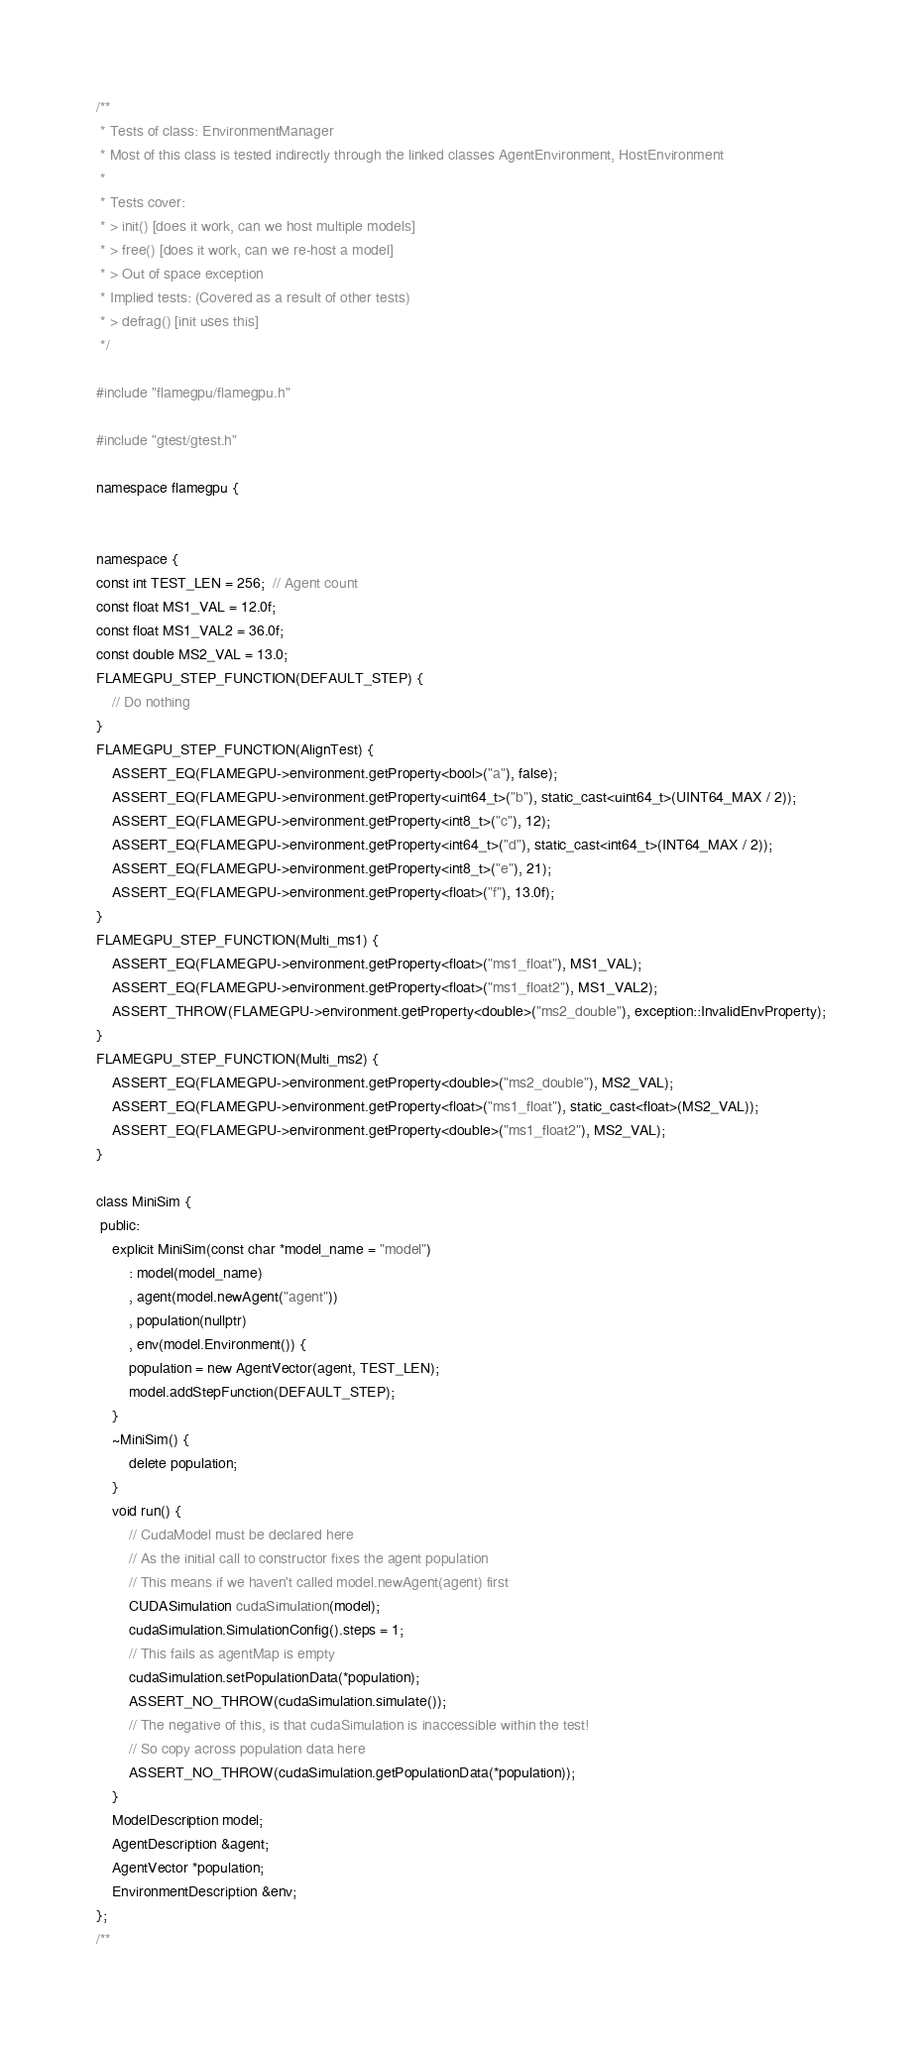<code> <loc_0><loc_0><loc_500><loc_500><_Cuda_>/**
 * Tests of class: EnvironmentManager
 * Most of this class is tested indirectly through the linked classes AgentEnvironment, HostEnvironment
 * 
 * Tests cover:
 * > init() [does it work, can we host multiple models]
 * > free() [does it work, can we re-host a model]
 * > Out of space exception
 * Implied tests: (Covered as a result of other tests)
 * > defrag() [init uses this]
 */

#include "flamegpu/flamegpu.h"

#include "gtest/gtest.h"

namespace flamegpu {


namespace {
const int TEST_LEN = 256;  // Agent count
const float MS1_VAL = 12.0f;
const float MS1_VAL2 = 36.0f;
const double MS2_VAL = 13.0;
FLAMEGPU_STEP_FUNCTION(DEFAULT_STEP) {
    // Do nothing
}
FLAMEGPU_STEP_FUNCTION(AlignTest) {
    ASSERT_EQ(FLAMEGPU->environment.getProperty<bool>("a"), false);
    ASSERT_EQ(FLAMEGPU->environment.getProperty<uint64_t>("b"), static_cast<uint64_t>(UINT64_MAX / 2));
    ASSERT_EQ(FLAMEGPU->environment.getProperty<int8_t>("c"), 12);
    ASSERT_EQ(FLAMEGPU->environment.getProperty<int64_t>("d"), static_cast<int64_t>(INT64_MAX / 2));
    ASSERT_EQ(FLAMEGPU->environment.getProperty<int8_t>("e"), 21);
    ASSERT_EQ(FLAMEGPU->environment.getProperty<float>("f"), 13.0f);
}
FLAMEGPU_STEP_FUNCTION(Multi_ms1) {
    ASSERT_EQ(FLAMEGPU->environment.getProperty<float>("ms1_float"), MS1_VAL);
    ASSERT_EQ(FLAMEGPU->environment.getProperty<float>("ms1_float2"), MS1_VAL2);
    ASSERT_THROW(FLAMEGPU->environment.getProperty<double>("ms2_double"), exception::InvalidEnvProperty);
}
FLAMEGPU_STEP_FUNCTION(Multi_ms2) {
    ASSERT_EQ(FLAMEGPU->environment.getProperty<double>("ms2_double"), MS2_VAL);
    ASSERT_EQ(FLAMEGPU->environment.getProperty<float>("ms1_float"), static_cast<float>(MS2_VAL));
    ASSERT_EQ(FLAMEGPU->environment.getProperty<double>("ms1_float2"), MS2_VAL);
}

class MiniSim {
 public:
    explicit MiniSim(const char *model_name = "model")
        : model(model_name)
        , agent(model.newAgent("agent"))
        , population(nullptr)
        , env(model.Environment()) {
        population = new AgentVector(agent, TEST_LEN);
        model.addStepFunction(DEFAULT_STEP);
    }
    ~MiniSim() {
        delete population;
    }
    void run() {
        // CudaModel must be declared here
        // As the initial call to constructor fixes the agent population
        // This means if we haven't called model.newAgent(agent) first
        CUDASimulation cudaSimulation(model);
        cudaSimulation.SimulationConfig().steps = 1;
        // This fails as agentMap is empty
        cudaSimulation.setPopulationData(*population);
        ASSERT_NO_THROW(cudaSimulation.simulate());
        // The negative of this, is that cudaSimulation is inaccessible within the test!
        // So copy across population data here
        ASSERT_NO_THROW(cudaSimulation.getPopulationData(*population));
    }
    ModelDescription model;
    AgentDescription &agent;
    AgentVector *population;
    EnvironmentDescription &env;
};
/**</code> 